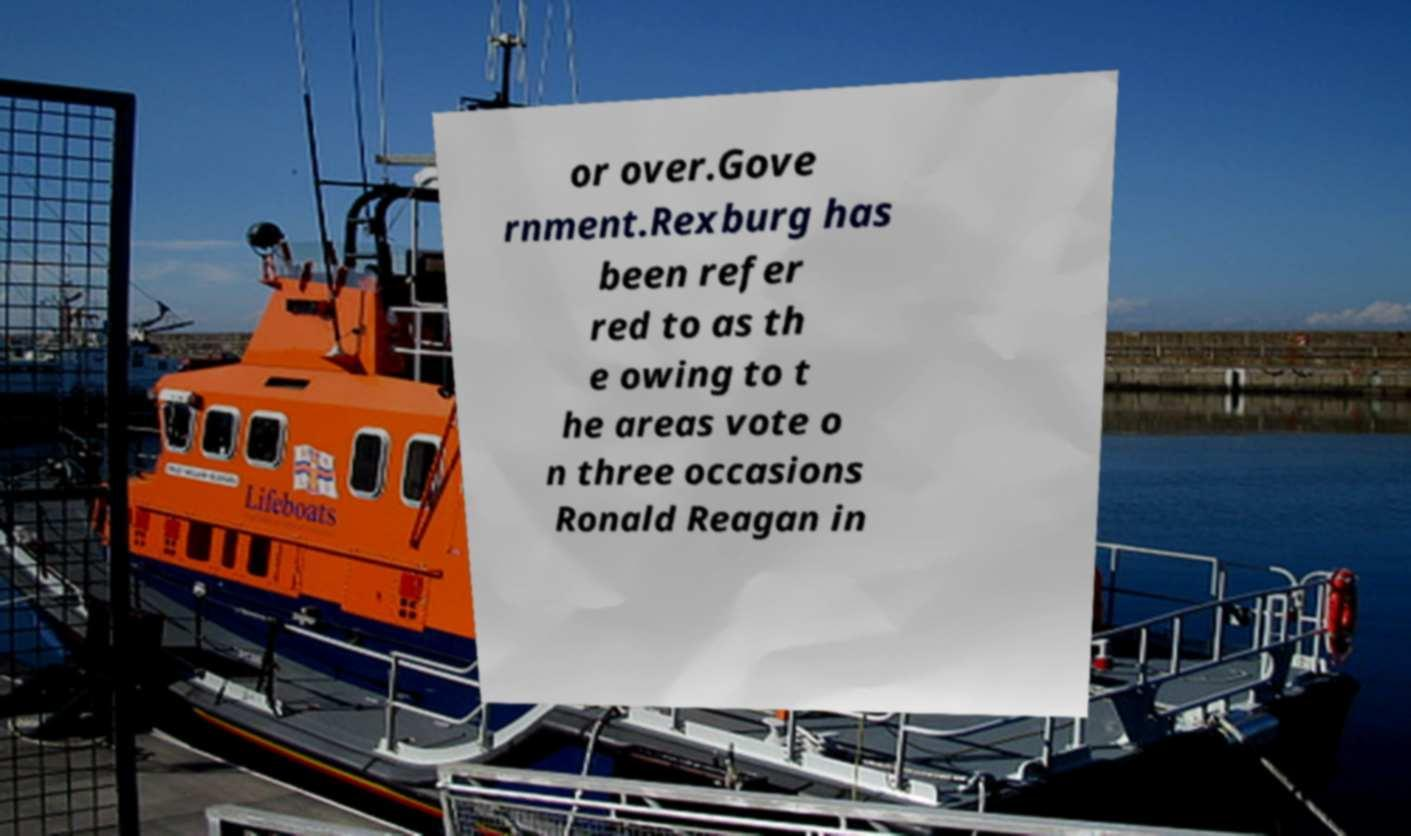What messages or text are displayed in this image? I need them in a readable, typed format. or over.Gove rnment.Rexburg has been refer red to as th e owing to t he areas vote o n three occasions Ronald Reagan in 